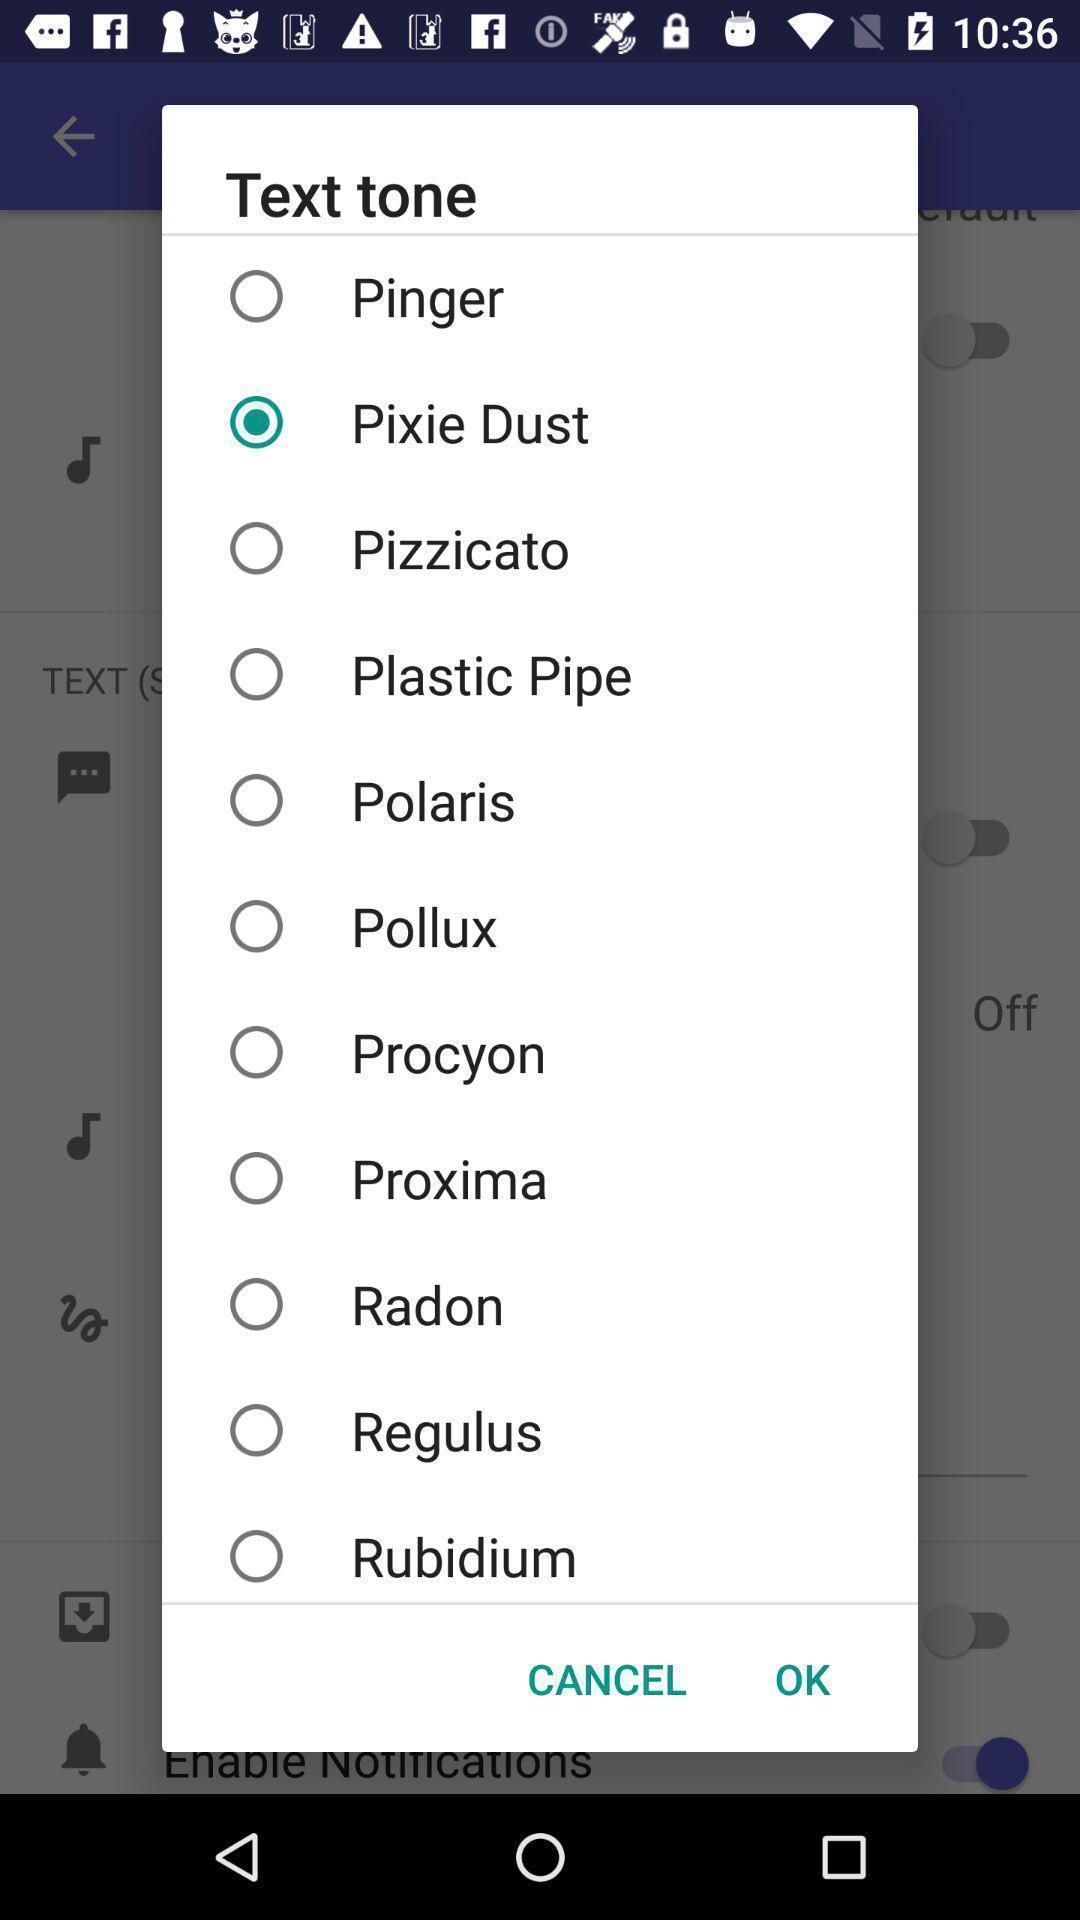Give me a summary of this screen capture. Pop-up for the list of text in an social application. 